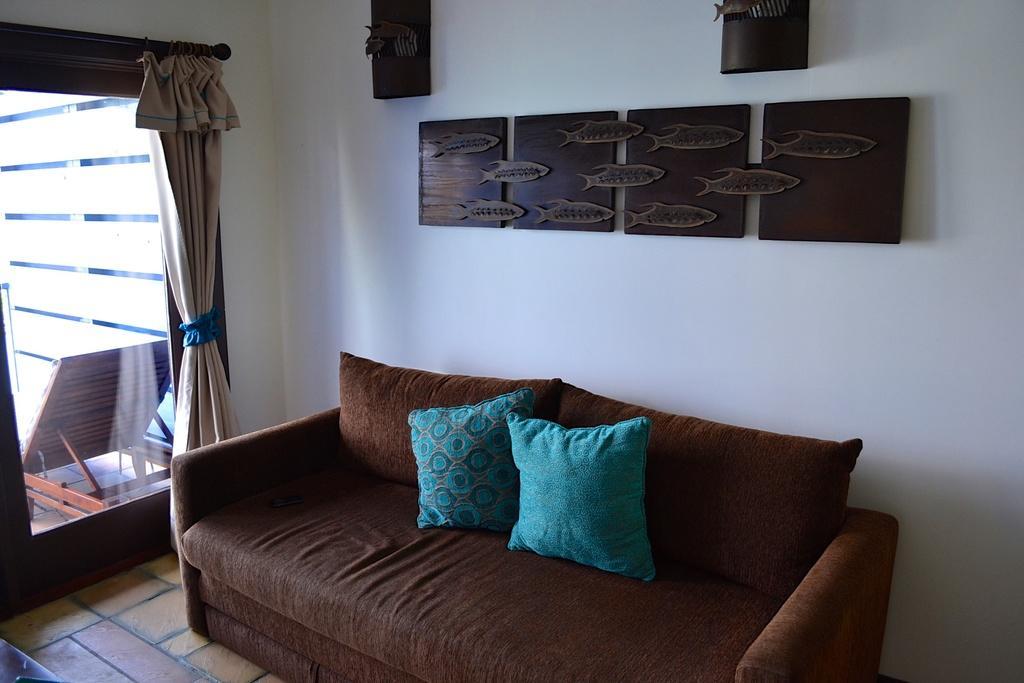Can you describe this image briefly? In this image, there is a sofa which in brown color, on that there are some pillows which are in blue color kept, in the left side there is a glass window which is in black color, in the background there is a white color wall and on that wall there are some black color pictures. 